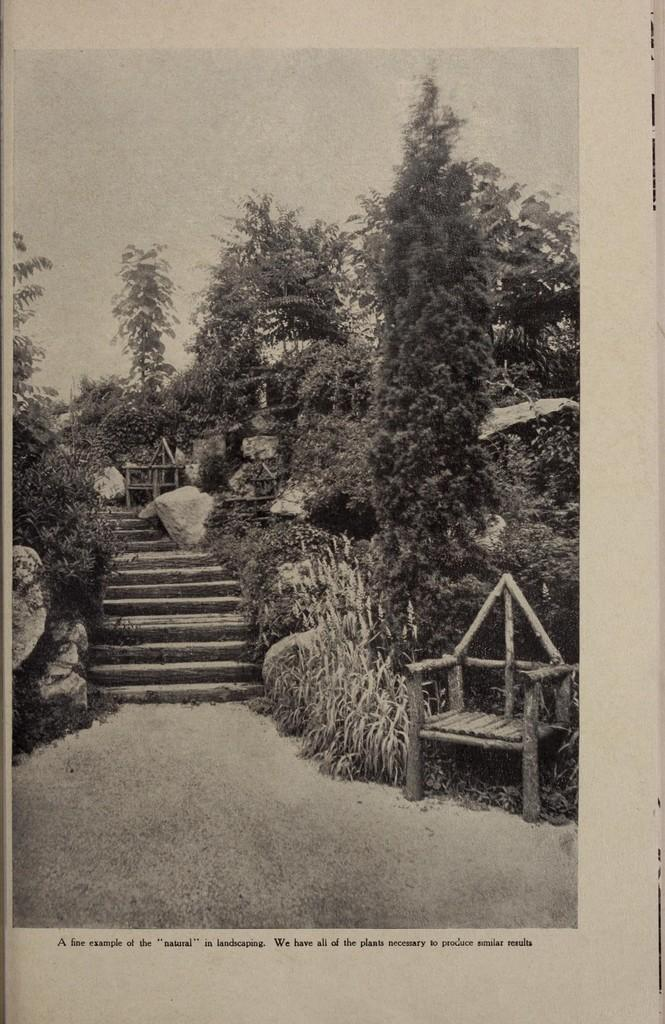What is the color scheme of the photo in the image? The photo in the image is black and white. What natural elements can be seen in the photo? There are trees in the photo. Are there any architectural features in the photo? Yes, there are steps in the photo. What part of the natural environment is visible in the photo? The sky is visible in the photo. Is there any text or writing on the photo? Yes, there is something written on the photo. What type of engine can be seen in the photo? There is no engine present in the photo; it features a black and white image with trees, steps, sky, and writing. Can you tell me how many kitties are sitting on the steps in the photo? There are no kitties present in the photo; it features a black and white image with trees, steps, sky, and writing. 